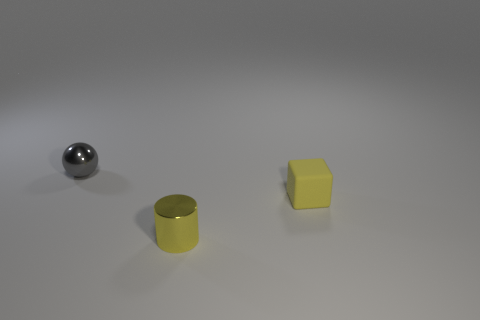What shape is the small yellow matte object? The small yellow object has the shape of a cube, featuring equal square faces on all sides and displaying a uniform matte finish that diffuses the light, giving it a softer appearance. 